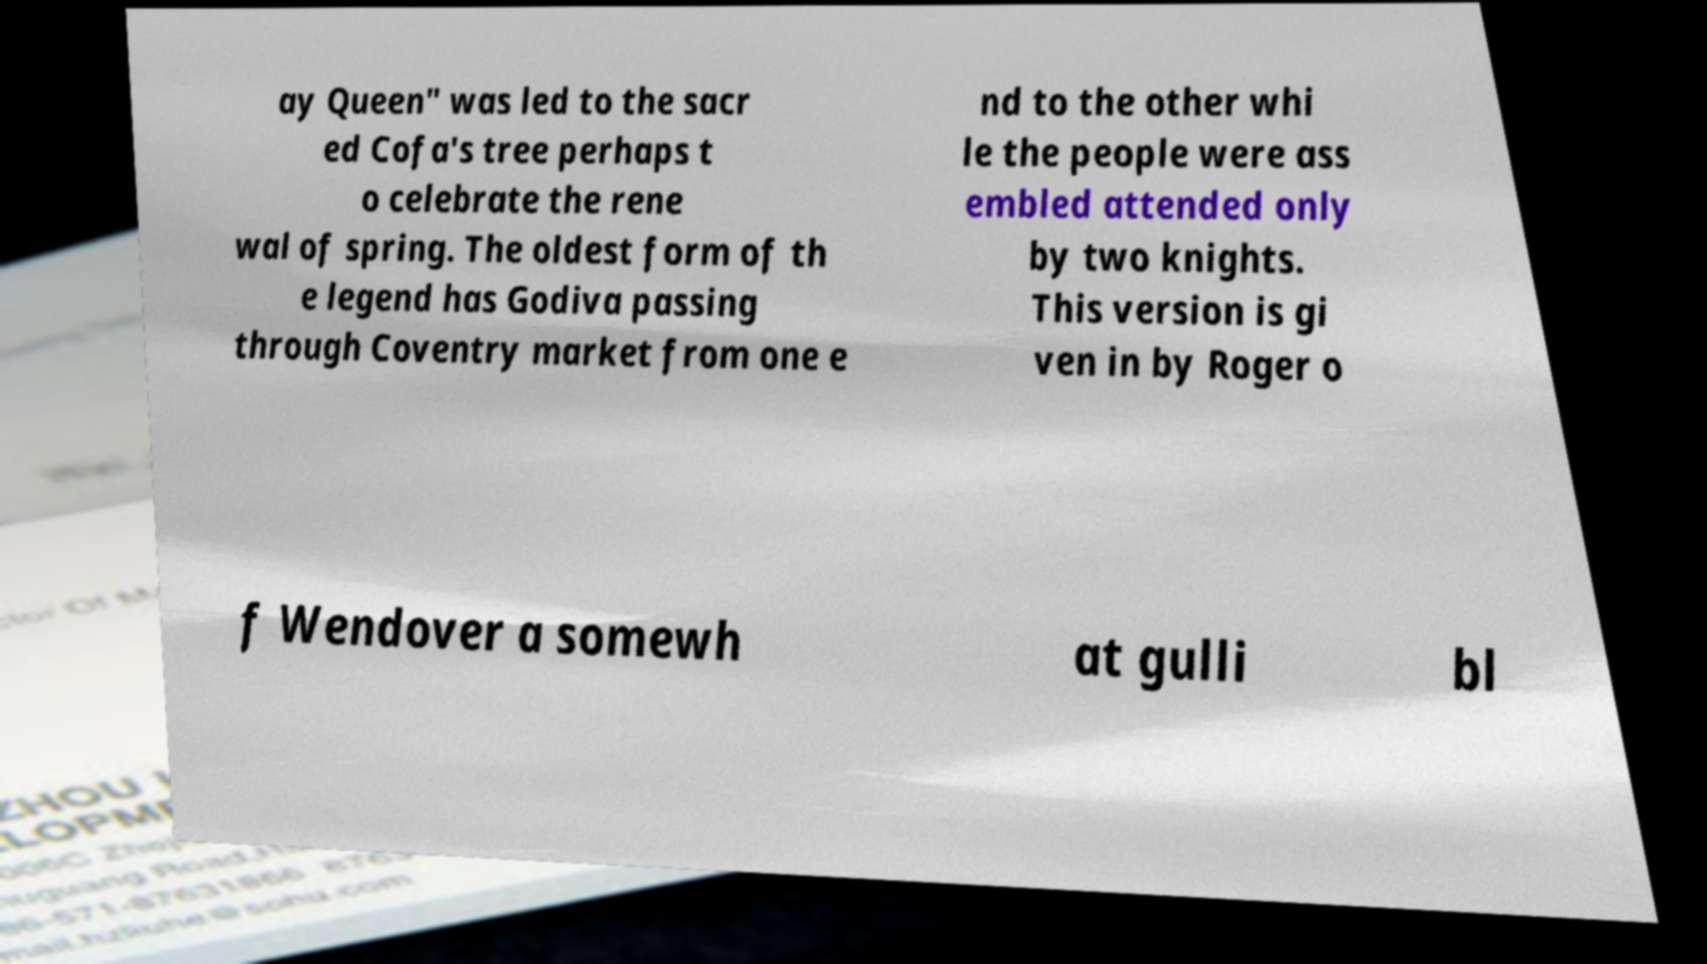Please identify and transcribe the text found in this image. ay Queen" was led to the sacr ed Cofa's tree perhaps t o celebrate the rene wal of spring. The oldest form of th e legend has Godiva passing through Coventry market from one e nd to the other whi le the people were ass embled attended only by two knights. This version is gi ven in by Roger o f Wendover a somewh at gulli bl 